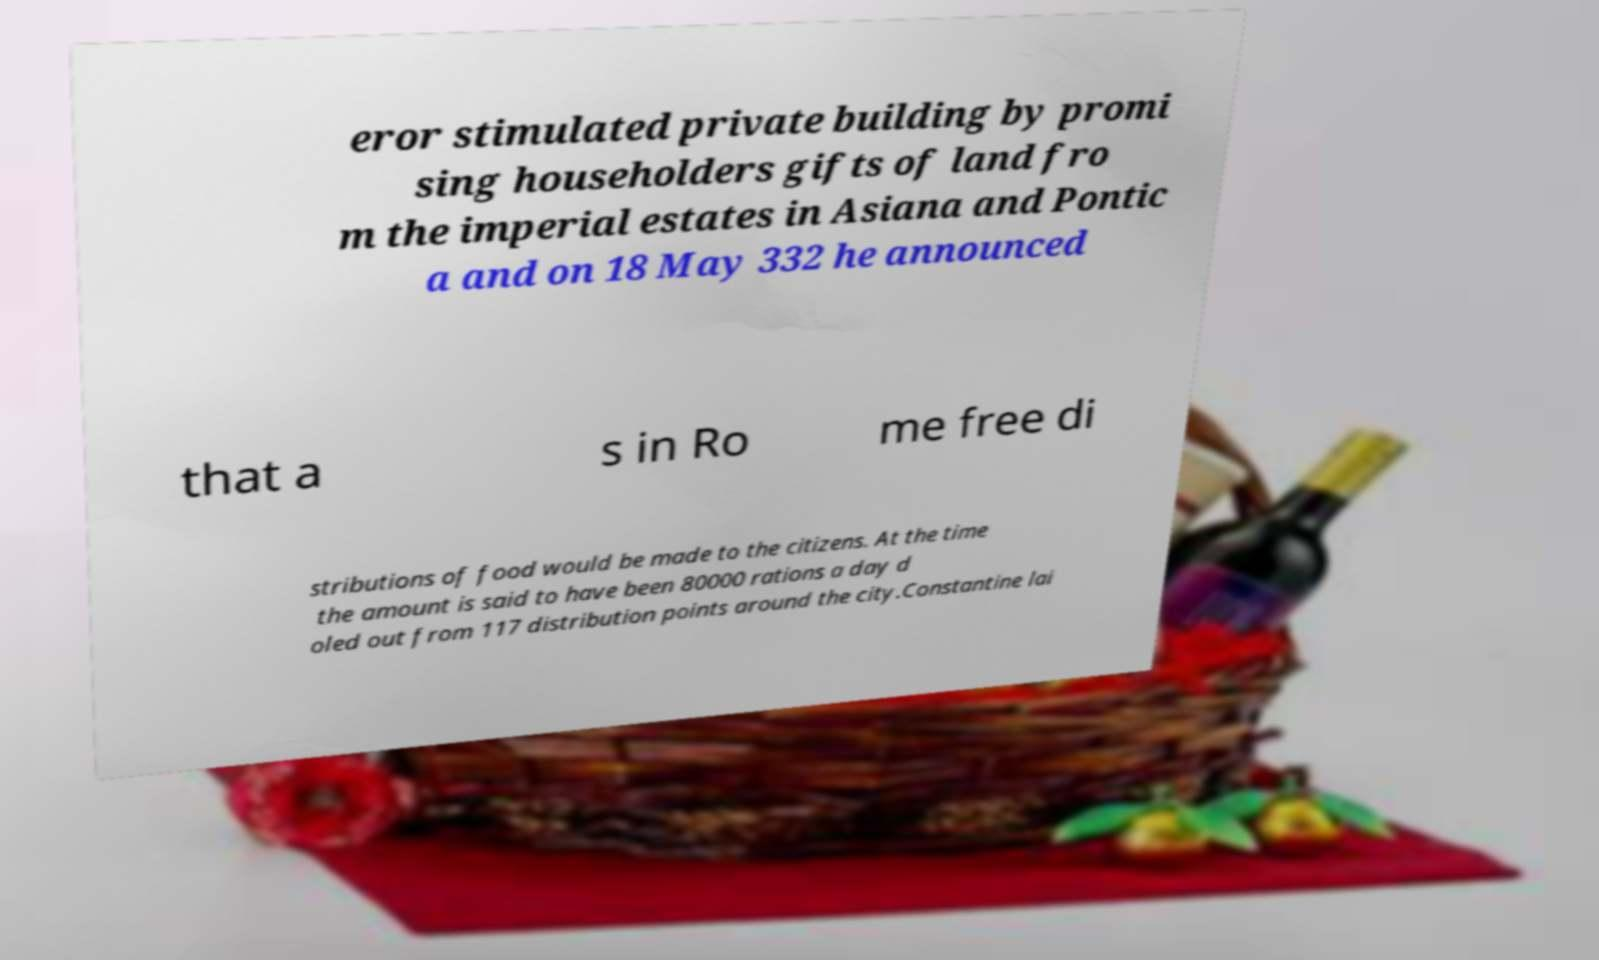Please read and relay the text visible in this image. What does it say? eror stimulated private building by promi sing householders gifts of land fro m the imperial estates in Asiana and Pontic a and on 18 May 332 he announced that a s in Ro me free di stributions of food would be made to the citizens. At the time the amount is said to have been 80000 rations a day d oled out from 117 distribution points around the city.Constantine lai 